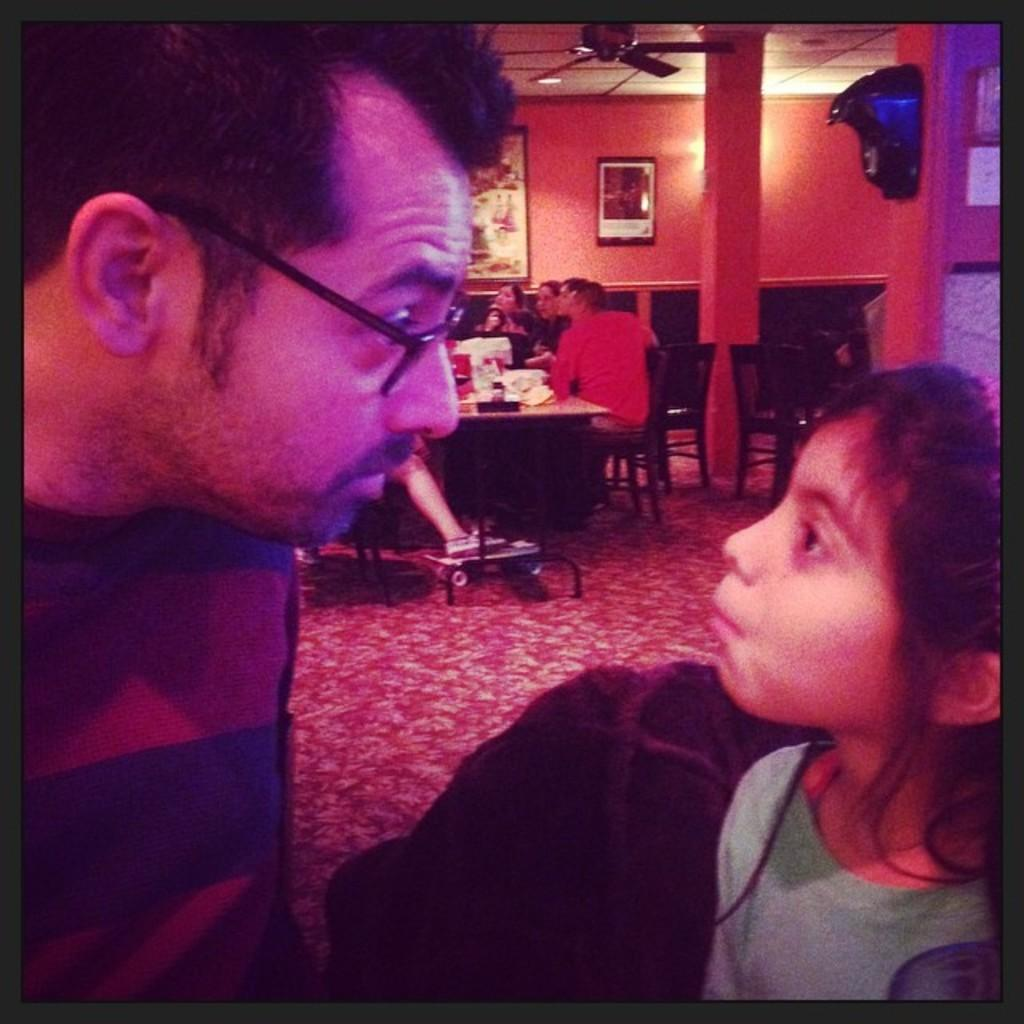What are the people in the image doing? There are people seated on chairs in the image. What is present on the table in the image? The information provided does not specify what is on the table. What can be seen on the wall in the image? There are photo frames on the wall in the image. Who are the people seated on the chairs? A man and a girl are seated on the chairs. What is providing air circulation in the image? There is a ceiling fan visible in the image. Are the people in the image playing a game of quince? There is no indication of a game of quince being played in the image. Can you see the man and the girl kissing in the image? There is no indication of the man and the girl kissing in the image. 